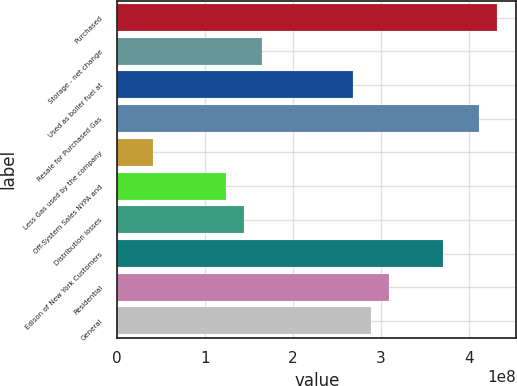Convert chart to OTSL. <chart><loc_0><loc_0><loc_500><loc_500><bar_chart><fcel>Purchased<fcel>Storage - net change<fcel>Used as boiler fuel at<fcel>Resale for Purchased Gas<fcel>Less Gas used by the company<fcel>Off-System Sales NYPA and<fcel>Distribution losses<fcel>Edison of New York Customers<fcel>Residential<fcel>General<nl><fcel>4.32415e+08<fcel>1.64729e+08<fcel>2.67685e+08<fcel>4.11823e+08<fcel>4.11824e+07<fcel>1.23547e+08<fcel>1.44138e+08<fcel>3.70641e+08<fcel>3.08868e+08<fcel>2.88276e+08<nl></chart> 